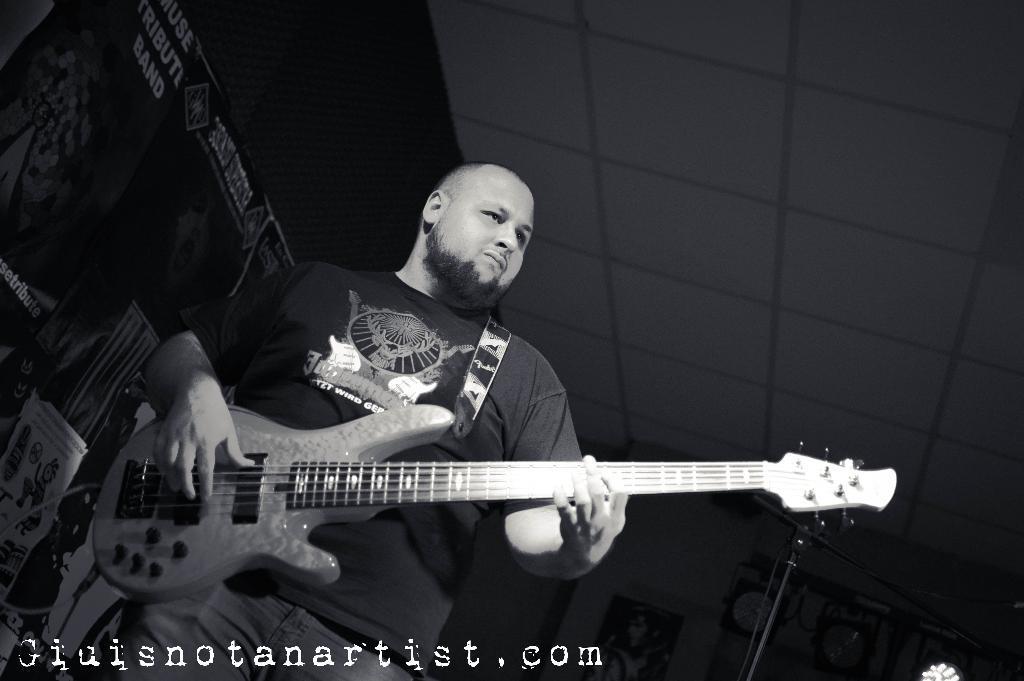Could you give a brief overview of what you see in this image? This is a black and white picture. here we can see a man standing and playing guitar. On the background we can see posters. 